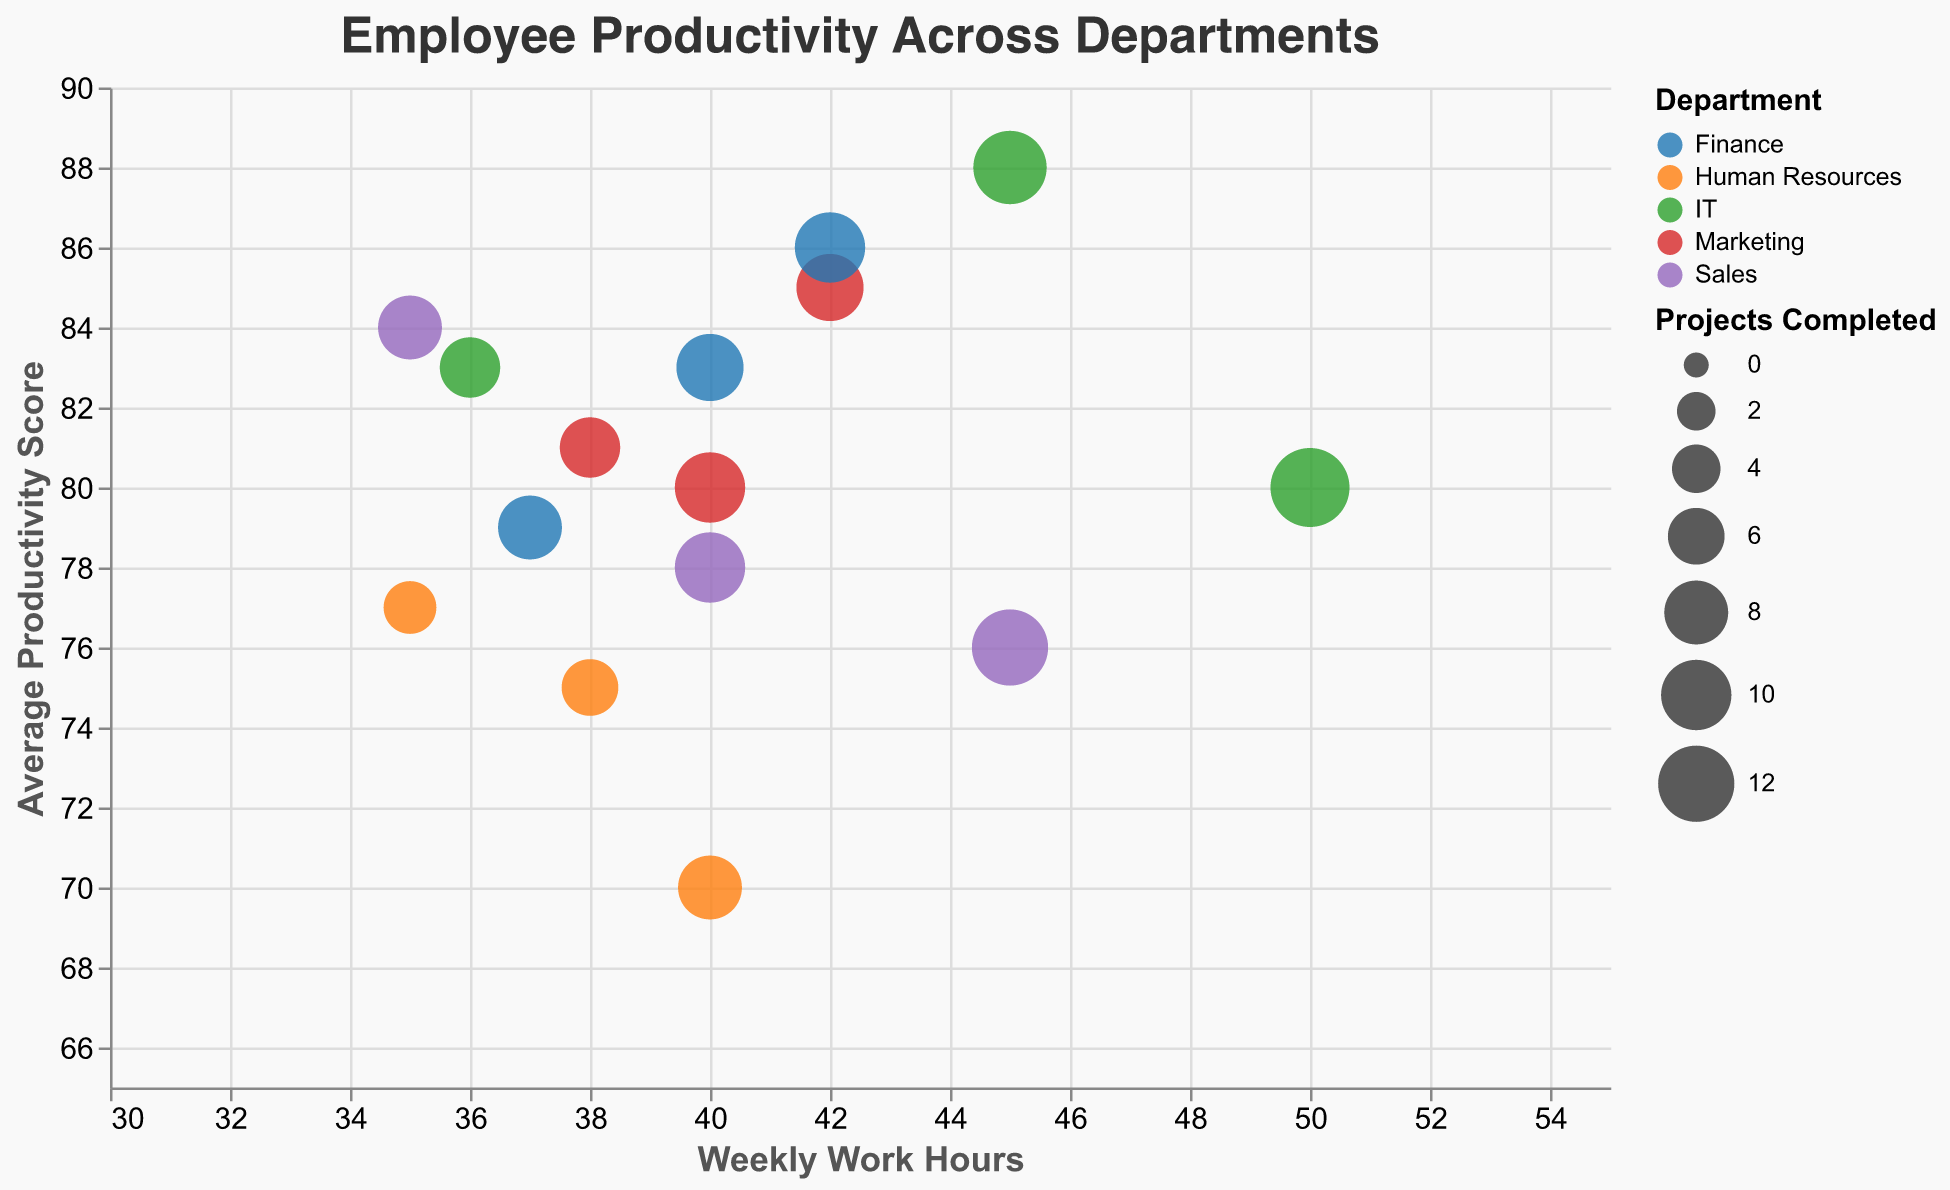How many employees are depicted from the Marketing department? Locate the color representing Marketing in the legend and count the number of circles with that color. There are 3 employees in the Marketing department: Emily Davis, Michael Johnson, and Sarah Wilson.
Answer: 3 What is the title of the figure? The title is positioned at the top of the figure in a larger font size. It reads "Employee Productivity Across Departments."
Answer: Employee Productivity Across Departments Which department has an employee with the highest Weekly Work Hours? First, locate the x-axis representing Weekly Work Hours. Look for the circle furthest to the right. The employee with the highest Weekly Work Hours, Ashley Martinez, is part of the IT department and works 50 hours.
Answer: IT What is the range of Average Productivity Scores in the IT department? Identify the color representing IT department employees. Look at the y-axis for the lowest and highest circle positions for these employees. Employees' Average Productivity Scores in the IT department range from 80 to 88.
Answer: 80 to 88 Which department has the least projects completed by any of its employees? Look for the smallest bubbles (circles) in the bubble chart, as they represent the least number of Projects Completed. The smallest bubble is from Kevin Clark in the Human Resources department with 5 projects.
Answer: Human Resources Who is the most productive employee on average in the Finance department? Locate the circles representing the Finance department based on color. Then, identify the circle positioned highest on the y-axis. Michelle Young has the highest Average Productivity Score of 86.
Answer: Michelle Young What is the difference in Weekly Work Hours between the employee with the highest productivity in the Sales department and the employee with the highest productivity in the Marketing department? Identify the most productive employee (highest on the y-axis) in both Sales and Marketing. Jane Smith from Sales works 35 hours, and Michael Johnson from Marketing works 42 hours. The difference in Weekly Work Hours is 42 - 35 = 7.
Answer: 7 Which department has the largest bubble representing the highest number of Projects Completed? Look for the largest bubbles in the chart and refer to the legend for the department color. The largest bubble belongs to Ashley Martinez in the IT department, completing 13 projects.
Answer: IT Compare the Average Productivity Scores of employees who work exactly 40 hours per week. What can you infer? Identify all circles aligned vertically with 40 on the x-axis. The employees are John Doe (Sales, 78), Sarah Wilson (Marketing, 80), Linda Harris (Human Resources, 70), and Steven Lewis (Finance, 83). The highest productivity score among these is from Steven Lewis in Finance.
Answer: Steven Lewis has the highest score among them What's the correlation between Average Productivity Score and Projects Completed for the IT department? Examine the position and size of the bubbles for the IT department. Generally, higher Average Productivity Scores also show larger bubble sizes, indicating a positive association between the two variables.
Answer: Positive correlation 